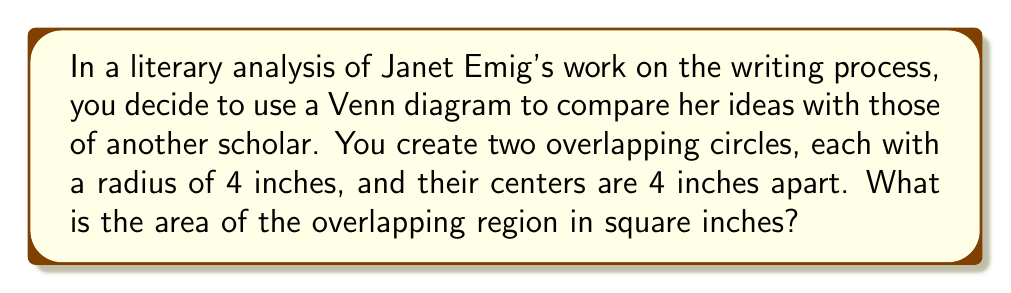Show me your answer to this math problem. Let's approach this step-by-step:

1) First, we need to recall the formula for the area of overlap between two equal circles. This area is given by:

   $$A = 2r^2 \arccos(\frac{d}{2r}) - d\sqrt{r^2 - \frac{d^2}{4}}$$

   Where $r$ is the radius of each circle and $d$ is the distance between their centers.

2) We're given that $r = 4$ inches and $d = 4$ inches. Let's substitute these values:

   $$A = 2(4^2) \arccos(\frac{4}{2(4)}) - 4\sqrt{4^2 - \frac{4^2}{4}}$$

3) Simplify inside the parentheses:

   $$A = 32 \arccos(\frac{1}{2}) - 4\sqrt{16 - 4}$$

4) Simplify under the square root:

   $$A = 32 \arccos(\frac{1}{2}) - 4\sqrt{12}$$

5) The value of $\arccos(\frac{1}{2})$ is $\frac{\pi}{3}$ radians or 60°. Let's use radians:

   $$A = 32 (\frac{\pi}{3}) - 4\sqrt{12}$$

6) Simplify:

   $$A = \frac{32\pi}{3} - 4\sqrt{12}$$

7) $\sqrt{12} = 2\sqrt{3}$, so:

   $$A = \frac{32\pi}{3} - 8\sqrt{3}$$

8) This is our final answer in exact form. If we want to approximate:

   $$A \approx 33.51 - 13.86 \approx 19.65 \text{ square inches}$$
Answer: $\frac{32\pi}{3} - 8\sqrt{3}$ square inches 